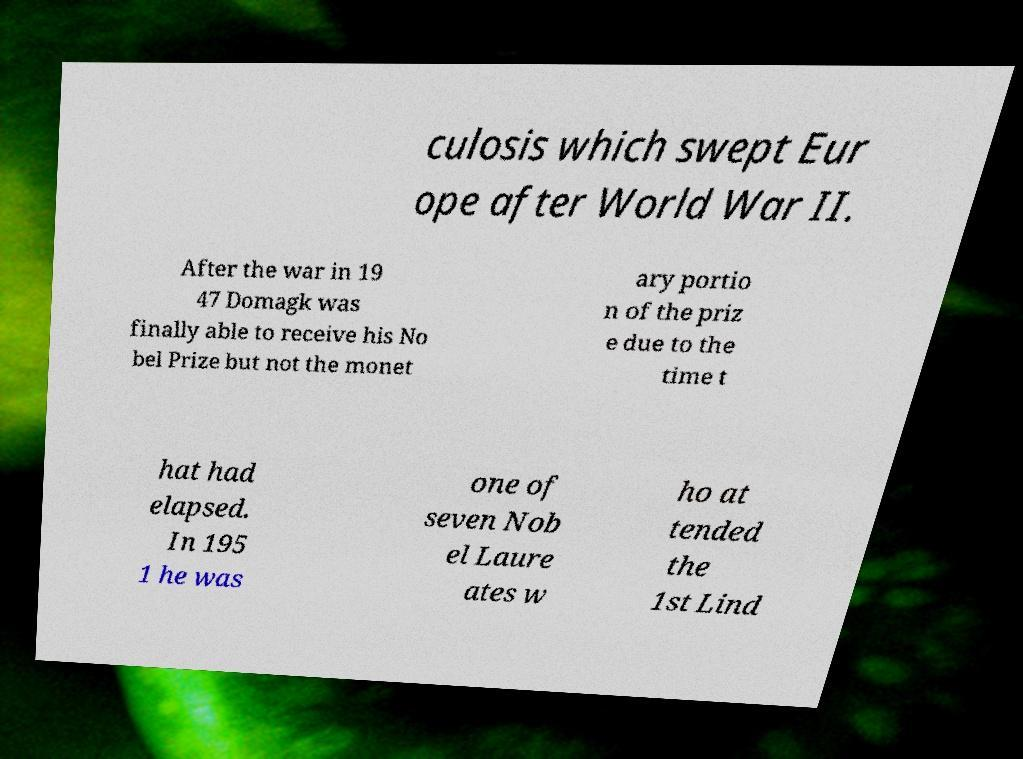Please read and relay the text visible in this image. What does it say? culosis which swept Eur ope after World War II. After the war in 19 47 Domagk was finally able to receive his No bel Prize but not the monet ary portio n of the priz e due to the time t hat had elapsed. In 195 1 he was one of seven Nob el Laure ates w ho at tended the 1st Lind 